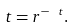Convert formula to latex. <formula><loc_0><loc_0><loc_500><loc_500>t = r ^ { - \ t } .</formula> 